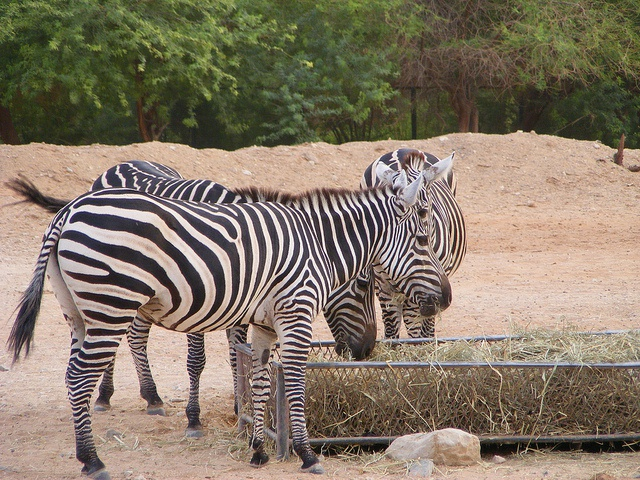Describe the objects in this image and their specific colors. I can see zebra in darkgreen, black, lightgray, gray, and darkgray tones, zebra in darkgreen, black, gray, darkgray, and maroon tones, and zebra in darkgreen, gray, lightgray, darkgray, and tan tones in this image. 